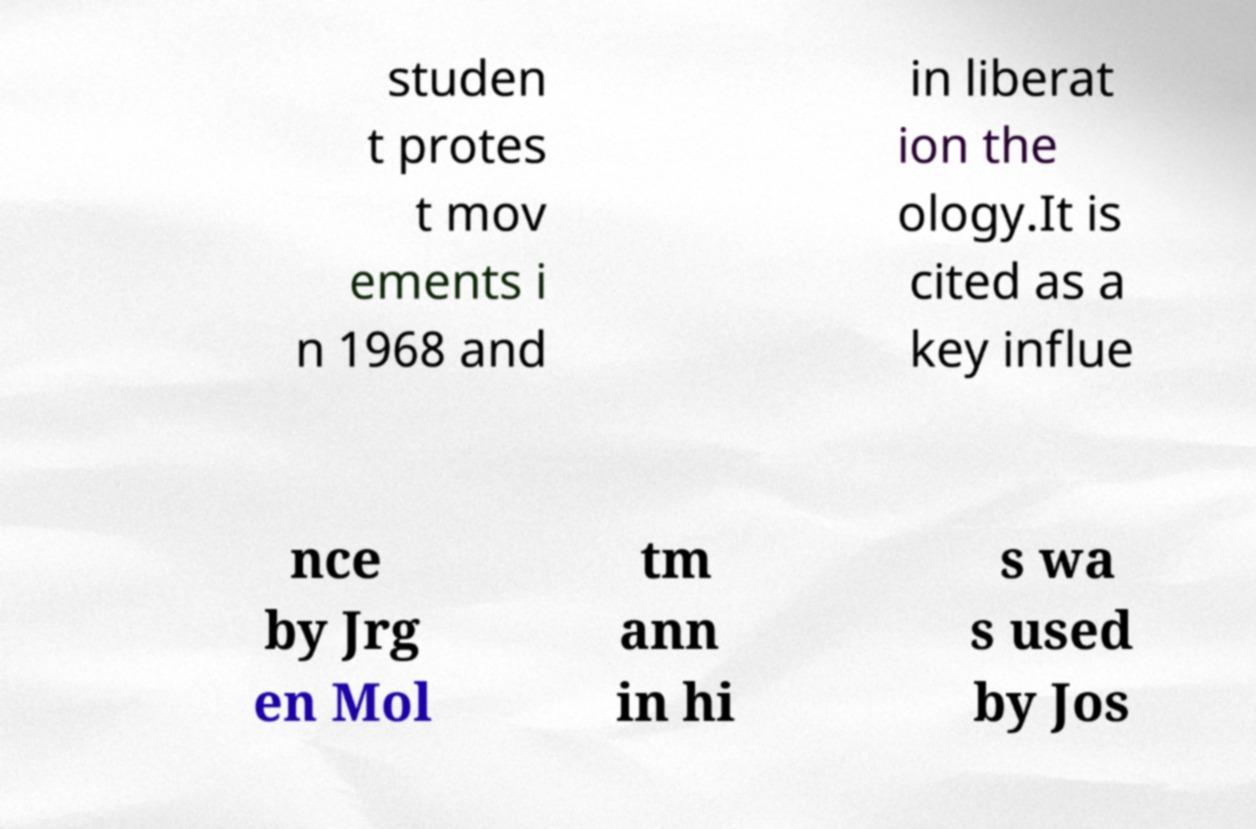Please read and relay the text visible in this image. What does it say? studen t protes t mov ements i n 1968 and in liberat ion the ology.It is cited as a key influe nce by Jrg en Mol tm ann in hi s wa s used by Jos 